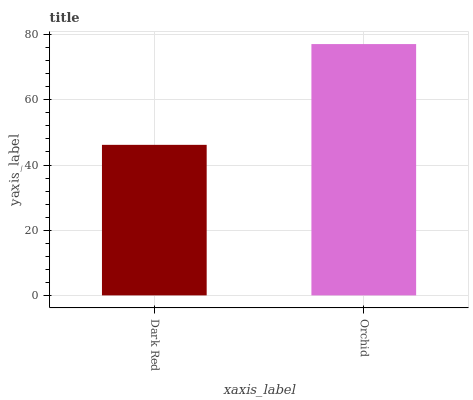Is Dark Red the minimum?
Answer yes or no. Yes. Is Orchid the maximum?
Answer yes or no. Yes. Is Orchid the minimum?
Answer yes or no. No. Is Orchid greater than Dark Red?
Answer yes or no. Yes. Is Dark Red less than Orchid?
Answer yes or no. Yes. Is Dark Red greater than Orchid?
Answer yes or no. No. Is Orchid less than Dark Red?
Answer yes or no. No. Is Orchid the high median?
Answer yes or no. Yes. Is Dark Red the low median?
Answer yes or no. Yes. Is Dark Red the high median?
Answer yes or no. No. Is Orchid the low median?
Answer yes or no. No. 